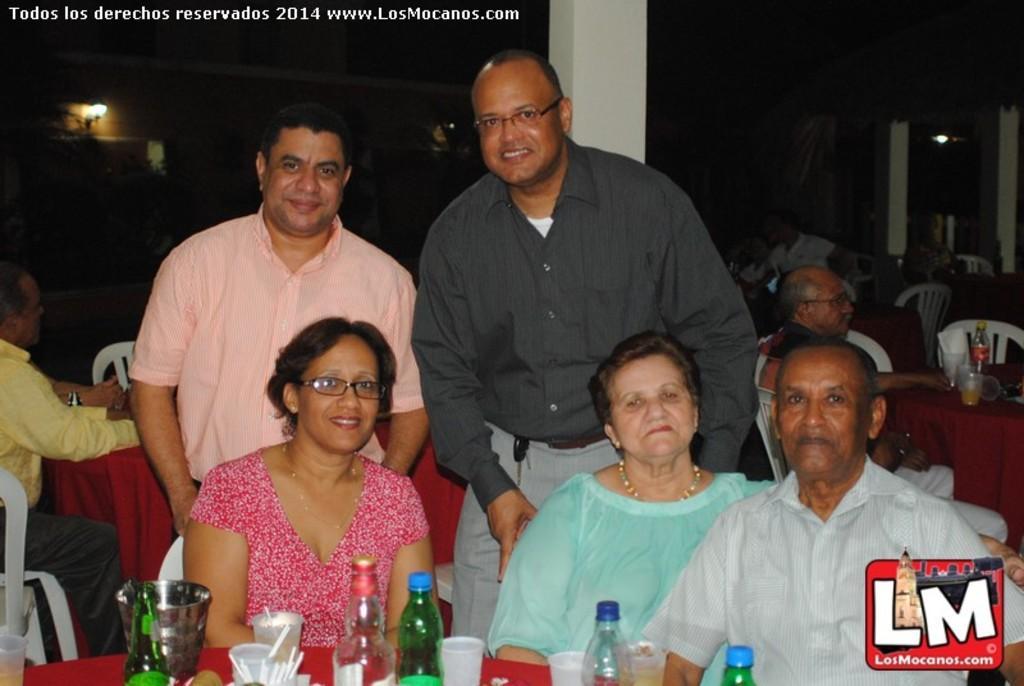Could you give a brief overview of what you see in this image? In this image we can see there are five people, in them three are sitting and two are standing with a smile on their face, in front of them there is a table. On the table there are some bottles, tissues and some other objects, beside them there are another few people sitting on their chairs, in front of the tables. The background is blurred. 